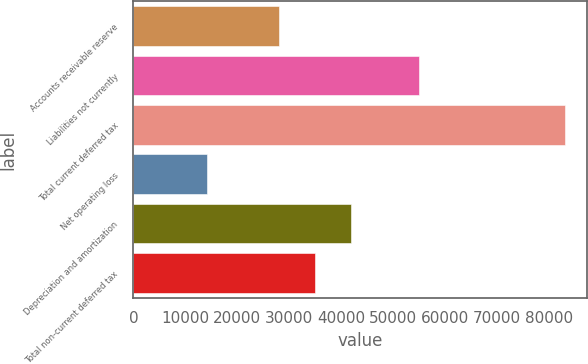Convert chart. <chart><loc_0><loc_0><loc_500><loc_500><bar_chart><fcel>Accounts receivable reserve<fcel>Liabilities not currently<fcel>Total current deferred tax<fcel>Net operating loss<fcel>Depreciation and amortization<fcel>Total non-current deferred tax<nl><fcel>28020<fcel>55010<fcel>83030<fcel>14247<fcel>41776.6<fcel>34898.3<nl></chart> 